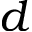Convert formula to latex. <formula><loc_0><loc_0><loc_500><loc_500>d</formula> 